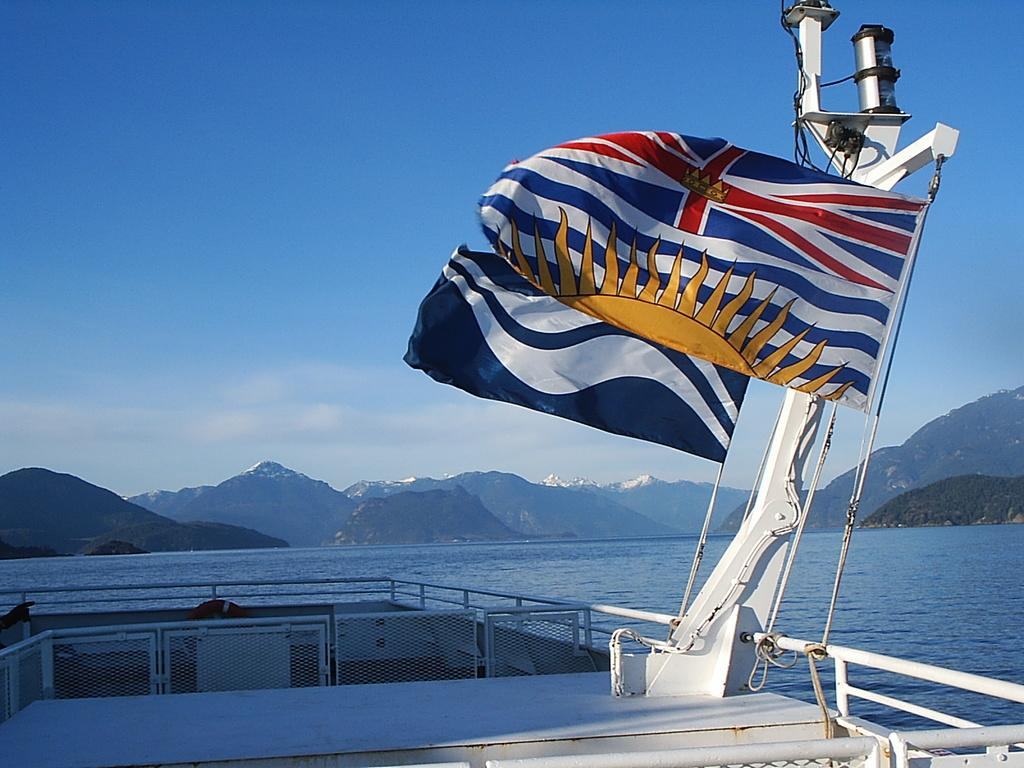What is the main subject of the image? The main subject of the image is a ship. Where is the ship located? The ship is in the ocean. What decorative or symbolic elements are on the ship? There are flags on the ship. What can be seen in the background of the image? There are mountains in the background of the image. What is visible above the ship and mountains? The sky is visible in the image, and clouds are present in the sky. Where is the tray located in the image? There is no tray present in the image. Can you describe the skateboarding competition happening in the background? There is no skateboarding competition or skateboard present in the image; it features a ship in the ocean with flags, mountains in the background, and clouds in the sky. 